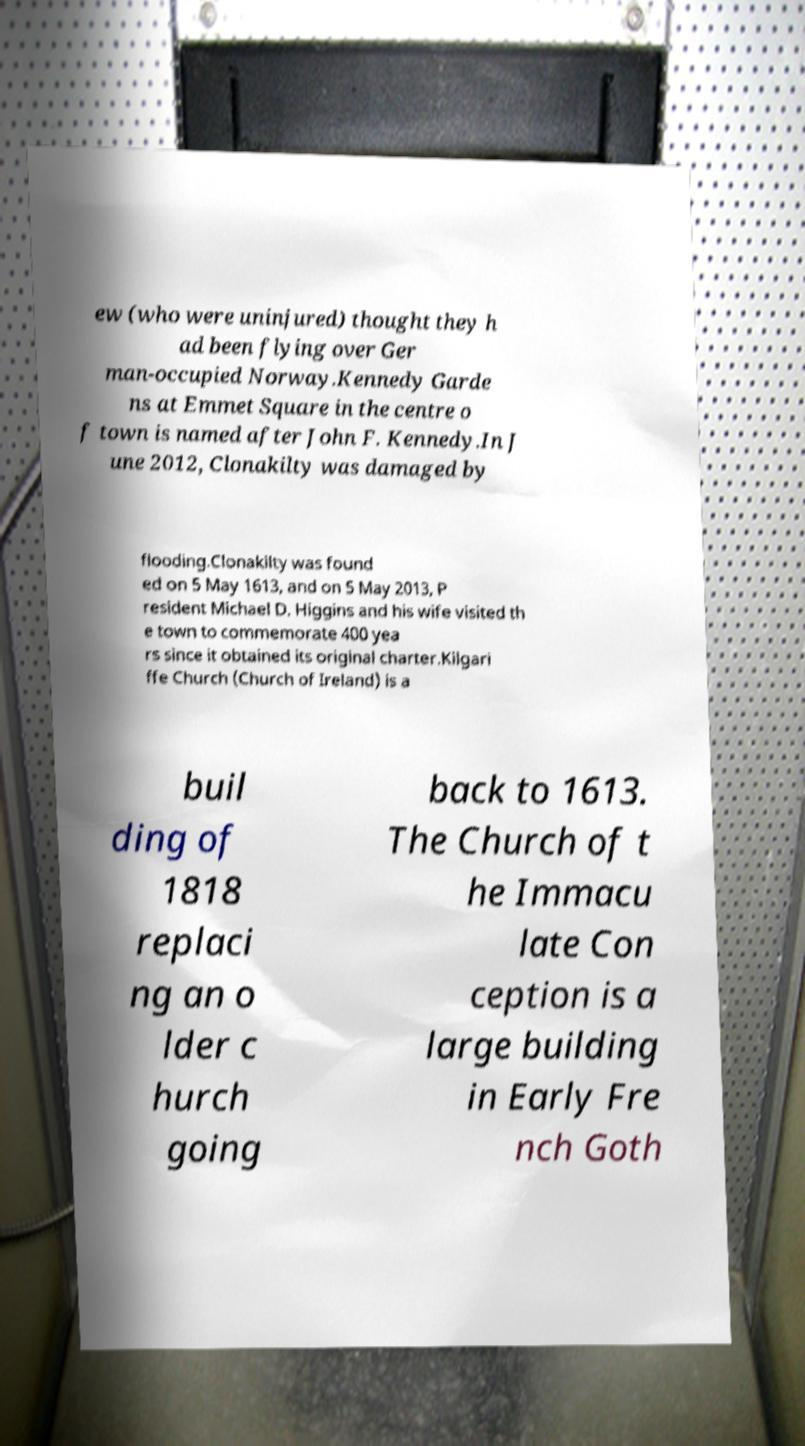Could you extract and type out the text from this image? ew (who were uninjured) thought they h ad been flying over Ger man-occupied Norway.Kennedy Garde ns at Emmet Square in the centre o f town is named after John F. Kennedy.In J une 2012, Clonakilty was damaged by flooding.Clonakilty was found ed on 5 May 1613, and on 5 May 2013, P resident Michael D. Higgins and his wife visited th e town to commemorate 400 yea rs since it obtained its original charter.Kilgari ffe Church (Church of Ireland) is a buil ding of 1818 replaci ng an o lder c hurch going back to 1613. The Church of t he Immacu late Con ception is a large building in Early Fre nch Goth 